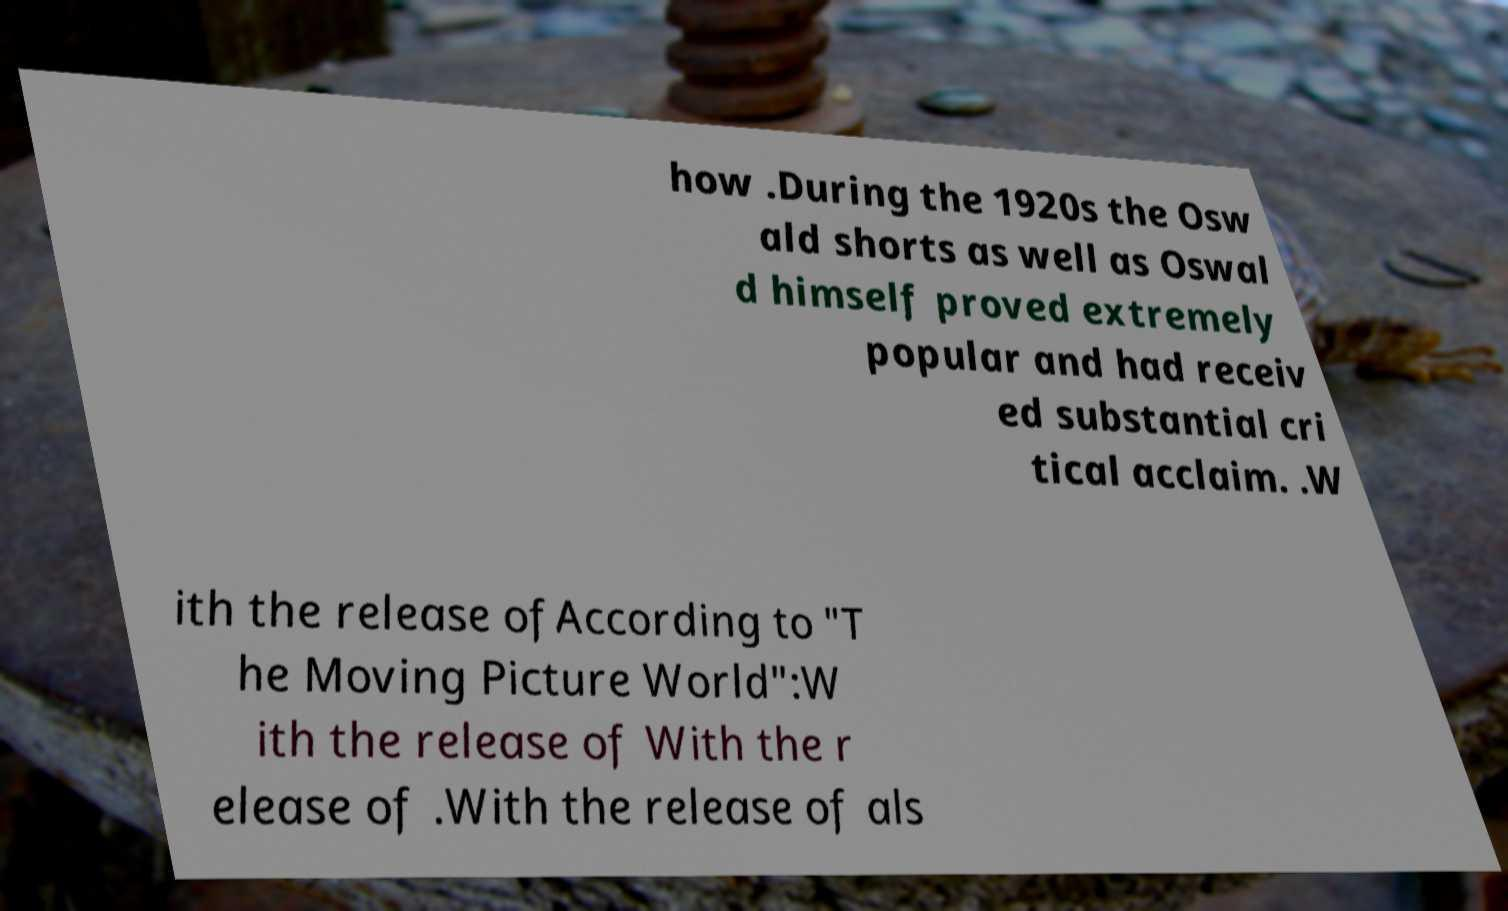Can you read and provide the text displayed in the image?This photo seems to have some interesting text. Can you extract and type it out for me? how .During the 1920s the Osw ald shorts as well as Oswal d himself proved extremely popular and had receiv ed substantial cri tical acclaim. .W ith the release ofAccording to "T he Moving Picture World":W ith the release of With the r elease of .With the release of als 